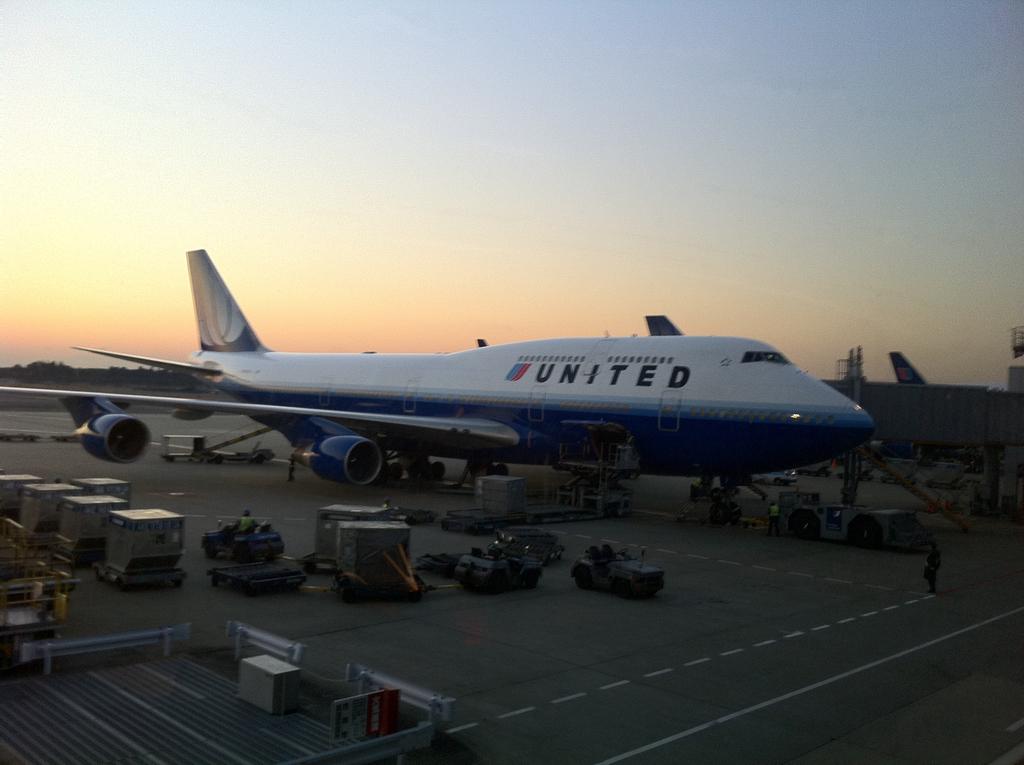What airlines is this plane from?
Provide a short and direct response. United. Which airline's name is written on the plane?
Ensure brevity in your answer.  United. 